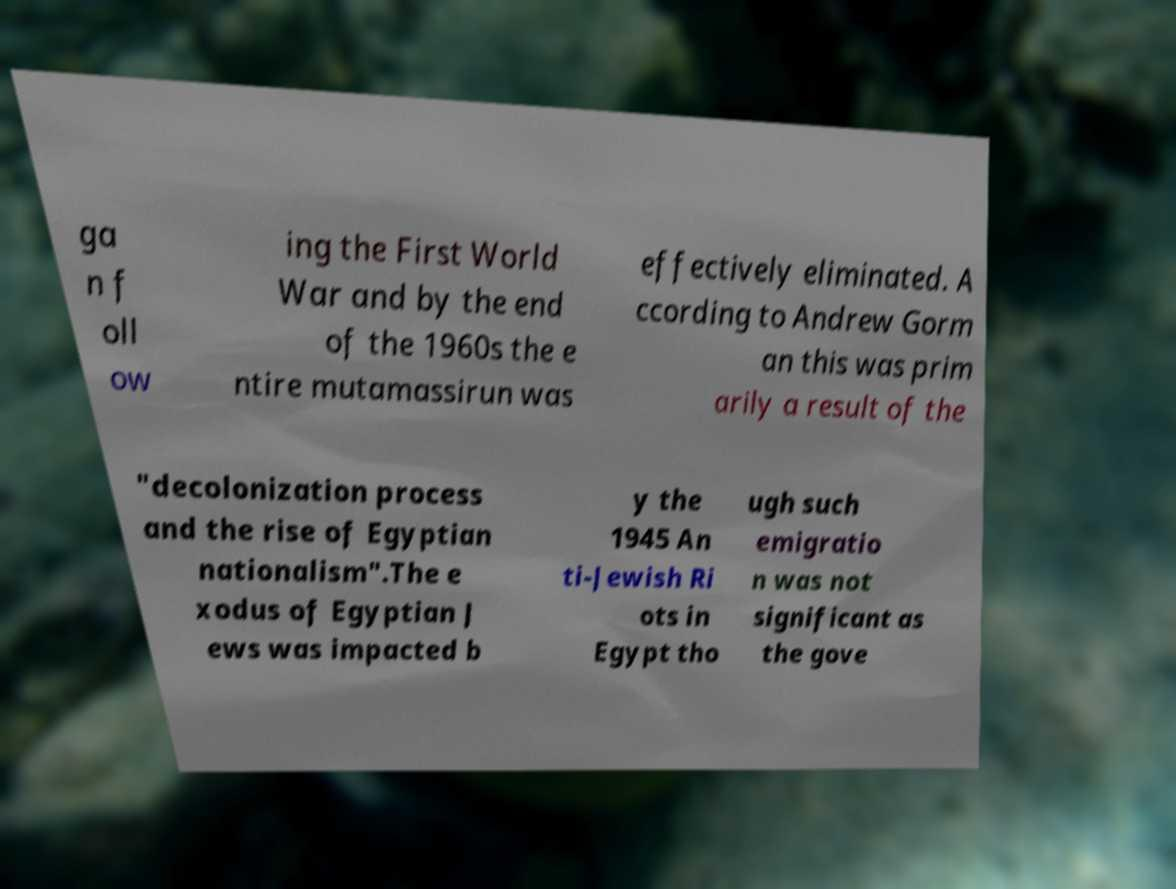Could you extract and type out the text from this image? ga n f oll ow ing the First World War and by the end of the 1960s the e ntire mutamassirun was effectively eliminated. A ccording to Andrew Gorm an this was prim arily a result of the "decolonization process and the rise of Egyptian nationalism".The e xodus of Egyptian J ews was impacted b y the 1945 An ti-Jewish Ri ots in Egypt tho ugh such emigratio n was not significant as the gove 